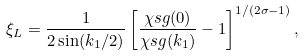Convert formula to latex. <formula><loc_0><loc_0><loc_500><loc_500>\xi _ { L } = \frac { 1 } { 2 \sin ( k _ { 1 } / 2 ) } \left [ \frac { \chi s g ( 0 ) } { \chi s g ( k _ { 1 } ) } - 1 \right ] ^ { 1 / ( 2 \sigma - 1 ) } ,</formula> 